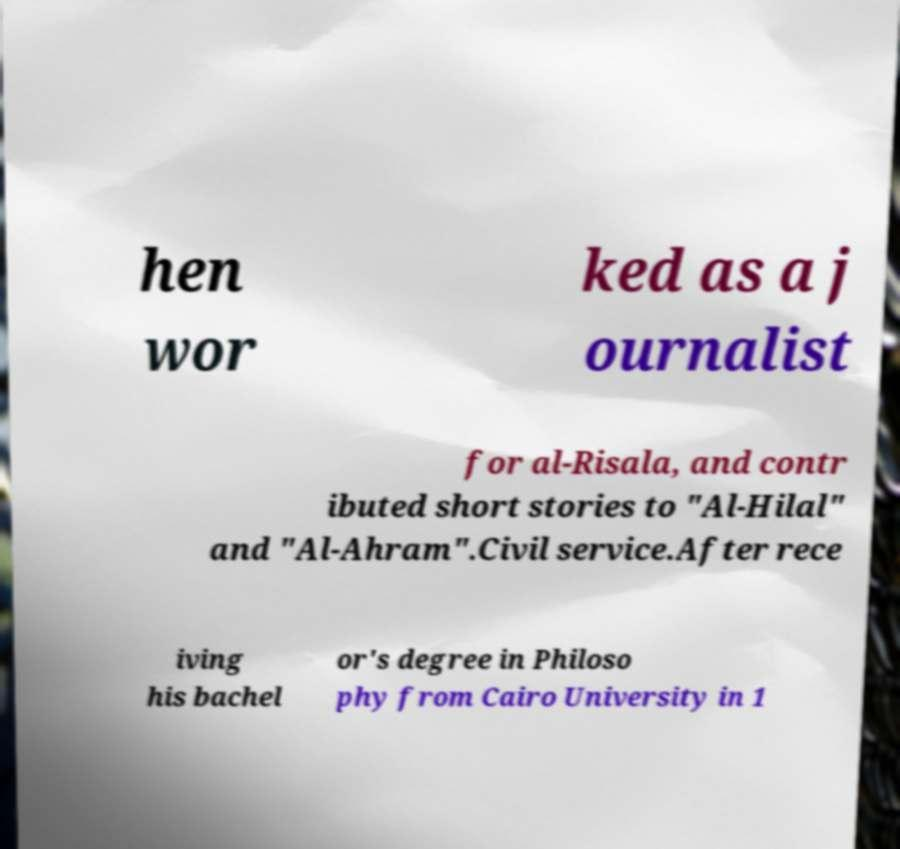Please read and relay the text visible in this image. What does it say? hen wor ked as a j ournalist for al-Risala, and contr ibuted short stories to "Al-Hilal" and "Al-Ahram".Civil service.After rece iving his bachel or's degree in Philoso phy from Cairo University in 1 